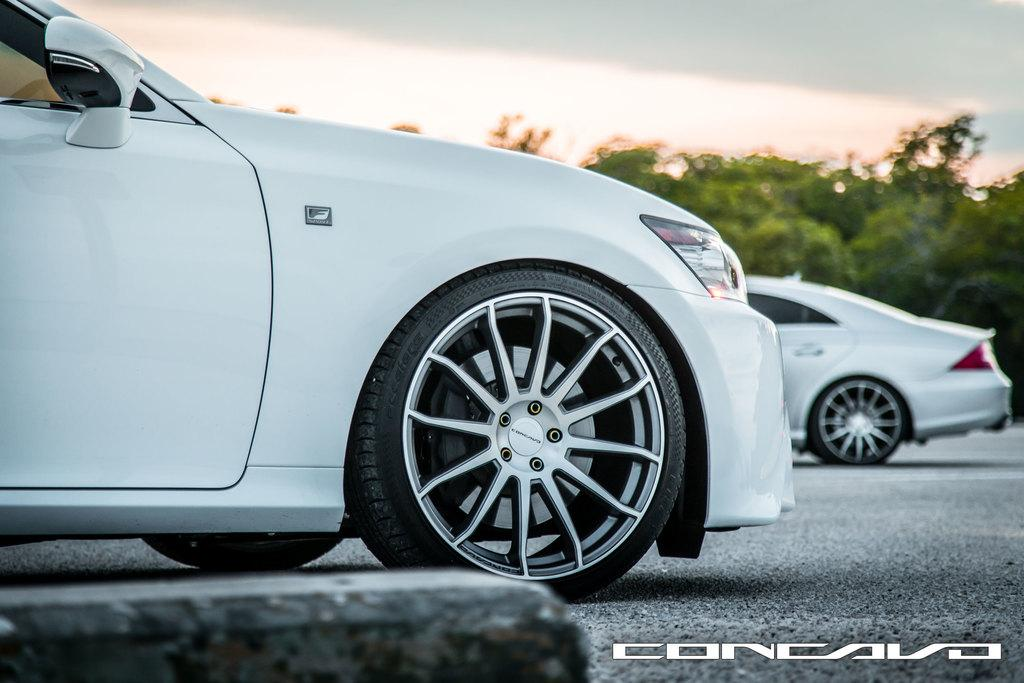How many cars are present in the image? There are two cars in the image. Where are the cars located? The cars are on a road in the image. What can be seen in the background behind the cars? There are many trees visible behind the cars. What type of garden can be seen in the image? There is no garden present in the image; it features two cars on a road with trees in the background. What kind of art is displayed on the side of the cars? There is no art displayed on the side of the cars in the image. 